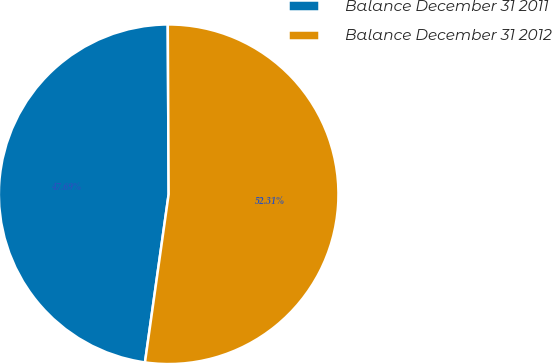<chart> <loc_0><loc_0><loc_500><loc_500><pie_chart><fcel>Balance December 31 2011<fcel>Balance December 31 2012<nl><fcel>47.69%<fcel>52.31%<nl></chart> 